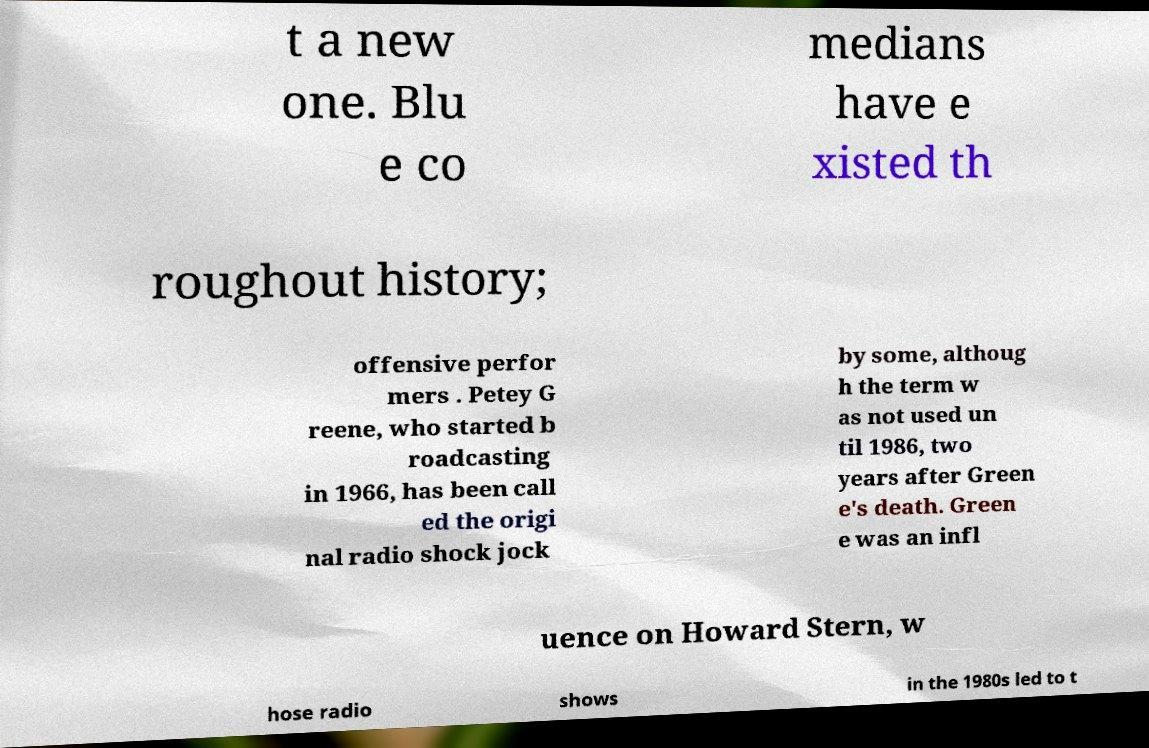Can you accurately transcribe the text from the provided image for me? t a new one. Blu e co medians have e xisted th roughout history; offensive perfor mers . Petey G reene, who started b roadcasting in 1966, has been call ed the origi nal radio shock jock by some, althoug h the term w as not used un til 1986, two years after Green e's death. Green e was an infl uence on Howard Stern, w hose radio shows in the 1980s led to t 